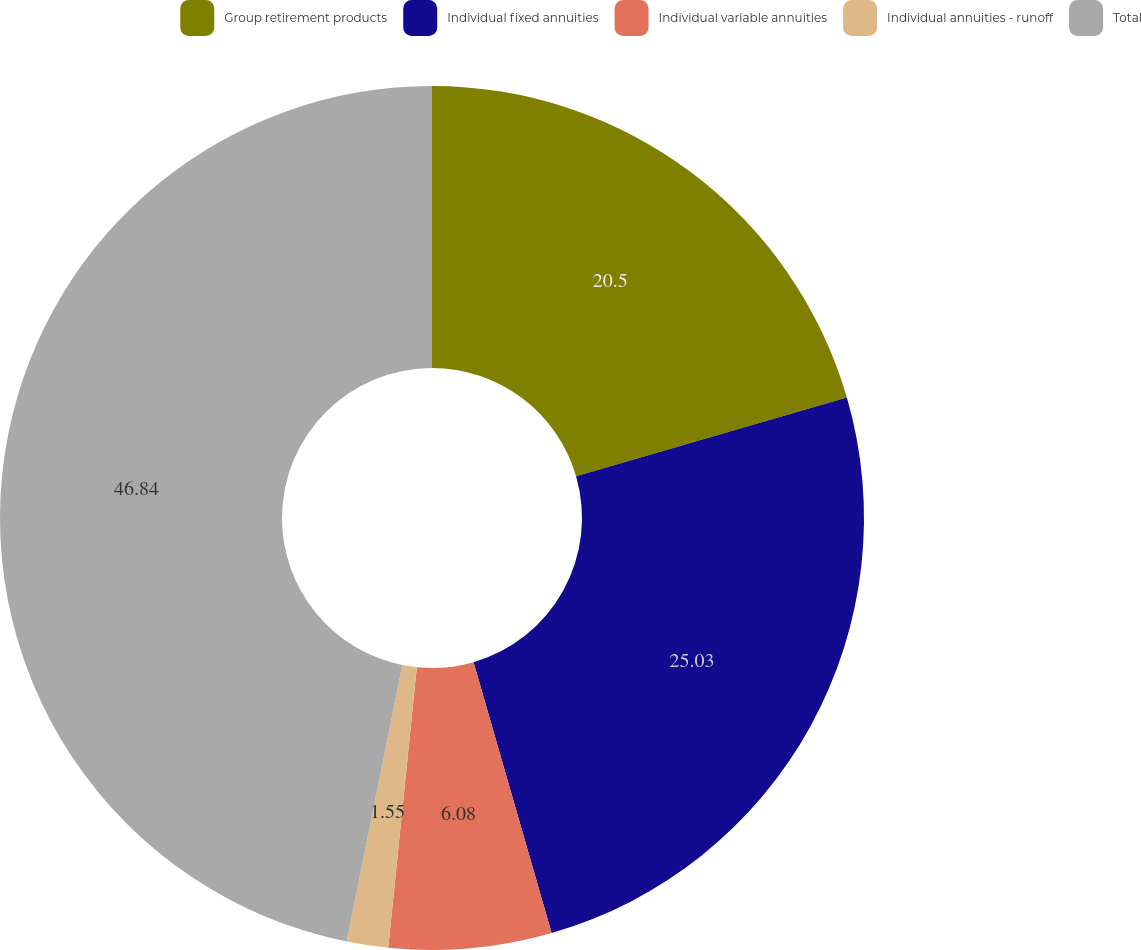Convert chart. <chart><loc_0><loc_0><loc_500><loc_500><pie_chart><fcel>Group retirement products<fcel>Individual fixed annuities<fcel>Individual variable annuities<fcel>Individual annuities - runoff<fcel>Total<nl><fcel>20.5%<fcel>25.03%<fcel>6.08%<fcel>1.55%<fcel>46.83%<nl></chart> 